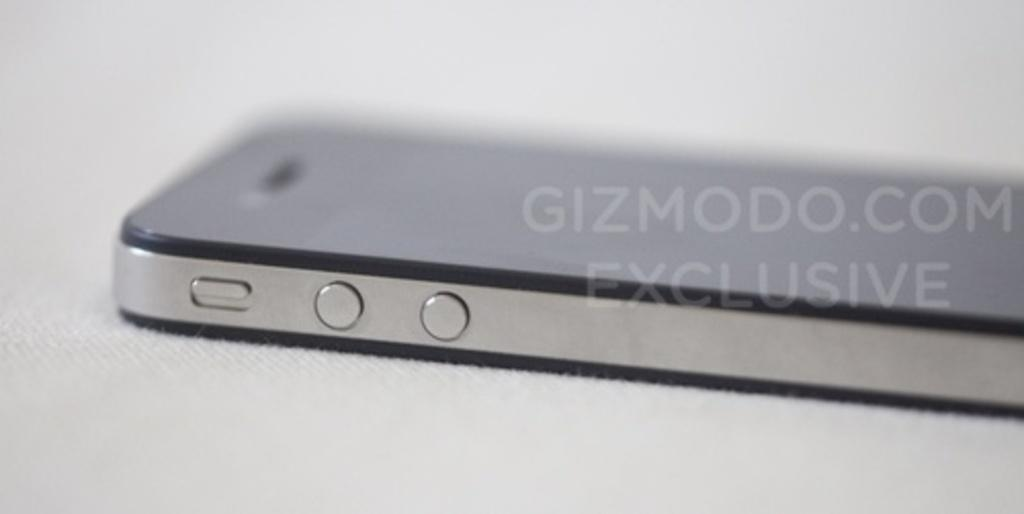Provide a one-sentence caption for the provided image. A closeup of a phone has a Gizmodo.com watermark over it. 